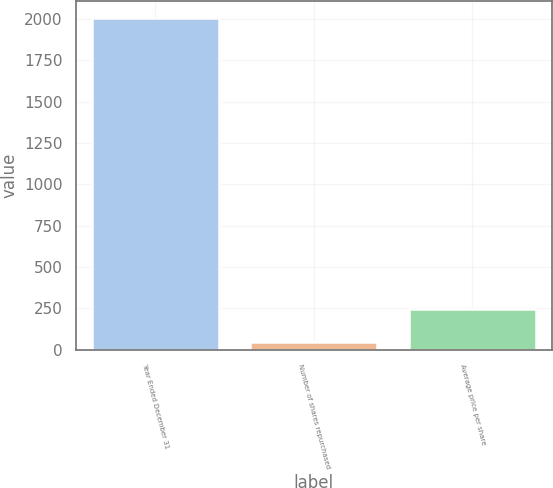Convert chart to OTSL. <chart><loc_0><loc_0><loc_500><loc_500><bar_chart><fcel>Year Ended December 31<fcel>Number of shares repurchased<fcel>Average price per share<nl><fcel>2010<fcel>49<fcel>245.1<nl></chart> 